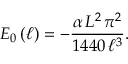Convert formula to latex. <formula><loc_0><loc_0><loc_500><loc_500>E _ { 0 } \left ( \ell \right ) = - \frac { \alpha \, L ^ { 2 } \, \pi ^ { 2 } } { 1 4 4 0 \, \ell ^ { 3 } } .</formula> 